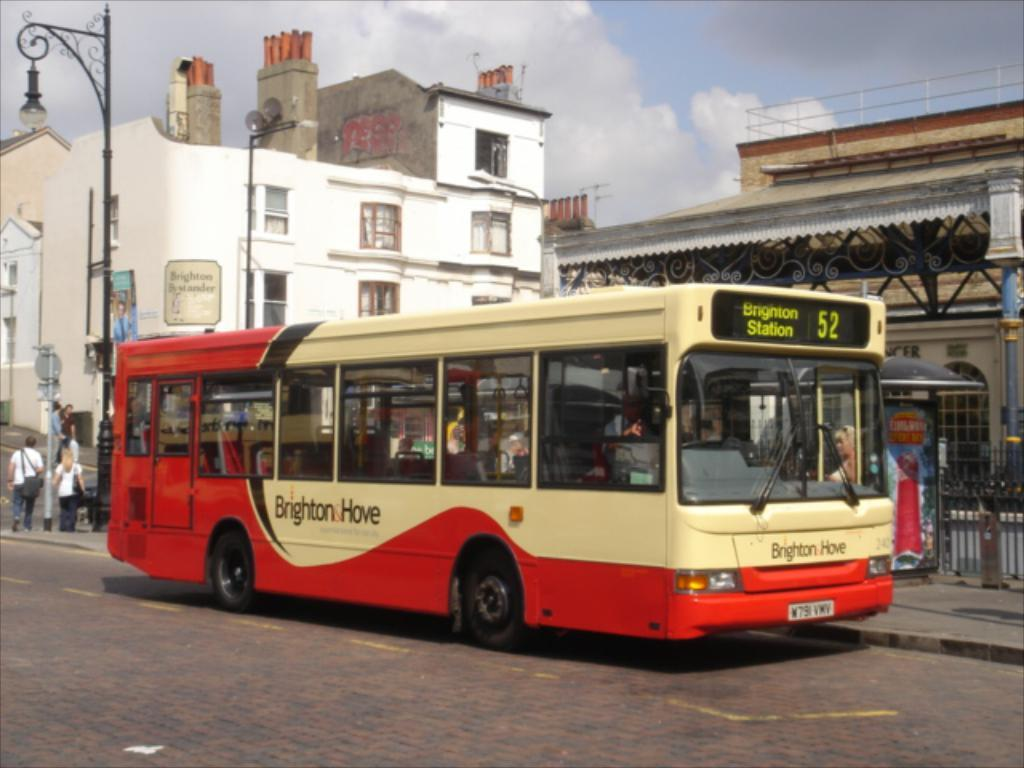<image>
Write a terse but informative summary of the picture. a bus that has the number 52 at the top 